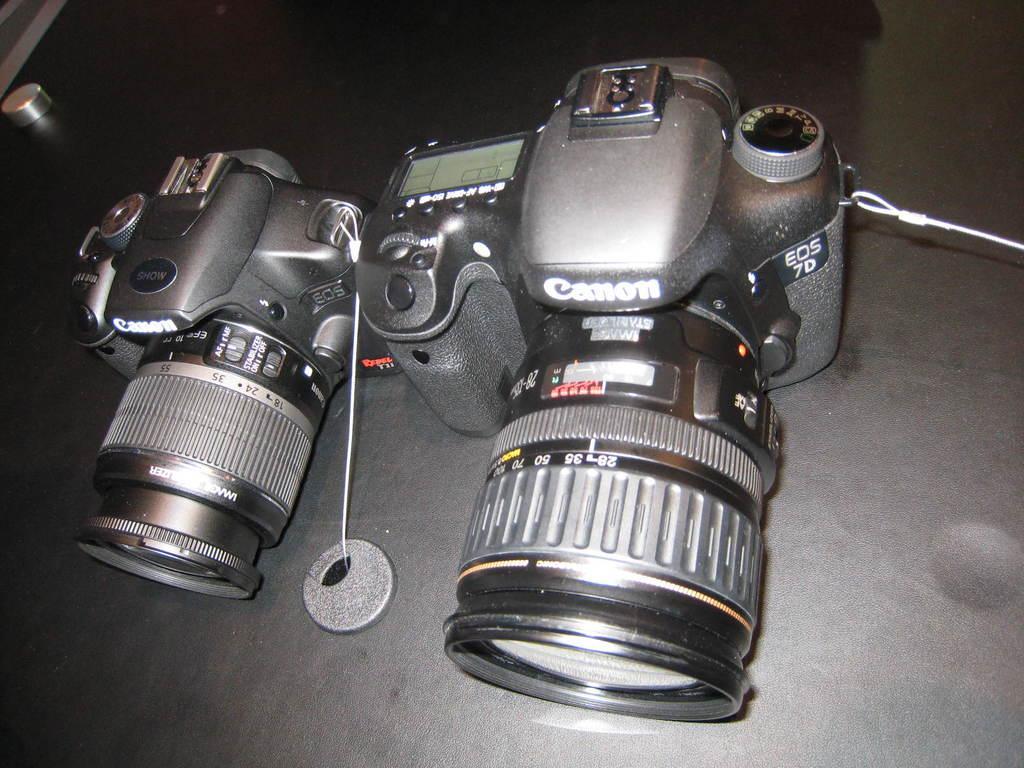Can you describe this image briefly? In this picture we can see a camera and an object on a black surface. 